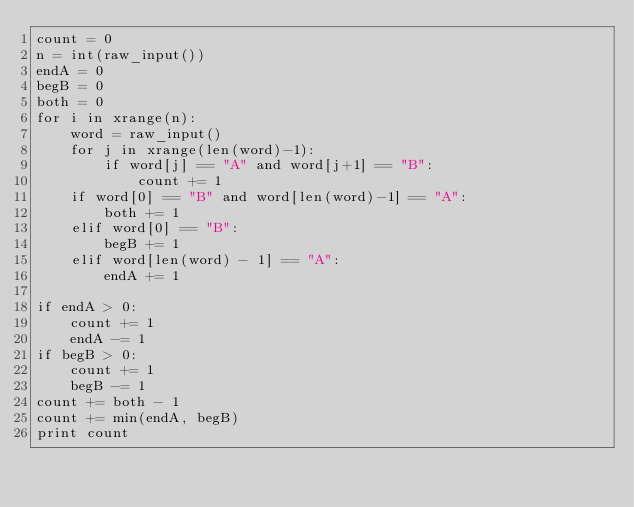<code> <loc_0><loc_0><loc_500><loc_500><_Python_>count = 0
n = int(raw_input())
endA = 0
begB = 0
both = 0
for i in xrange(n):
    word = raw_input()
    for j in xrange(len(word)-1):
        if word[j] == "A" and word[j+1] == "B":
            count += 1
    if word[0] == "B" and word[len(word)-1] == "A":
        both += 1
    elif word[0] == "B":
        begB += 1
    elif word[len(word) - 1] == "A":
        endA += 1

if endA > 0:
    count += 1
    endA -= 1
if begB > 0:
    count += 1
    begB -= 1
count += both - 1
count += min(endA, begB)
print count</code> 